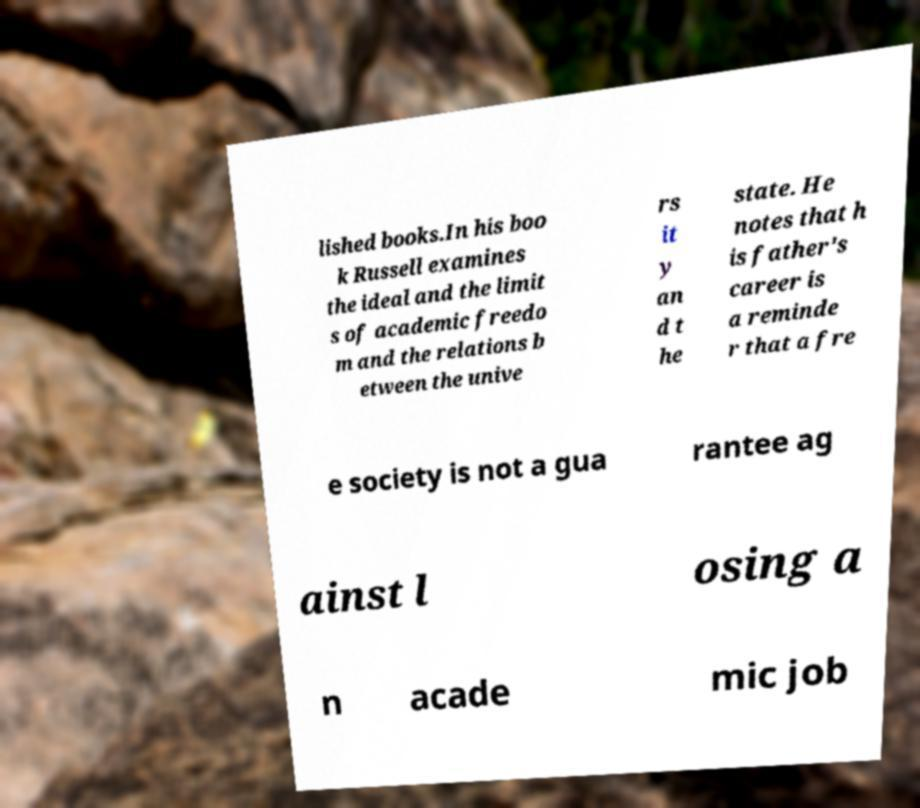Please read and relay the text visible in this image. What does it say? lished books.In his boo k Russell examines the ideal and the limit s of academic freedo m and the relations b etween the unive rs it y an d t he state. He notes that h is father's career is a reminde r that a fre e society is not a gua rantee ag ainst l osing a n acade mic job 